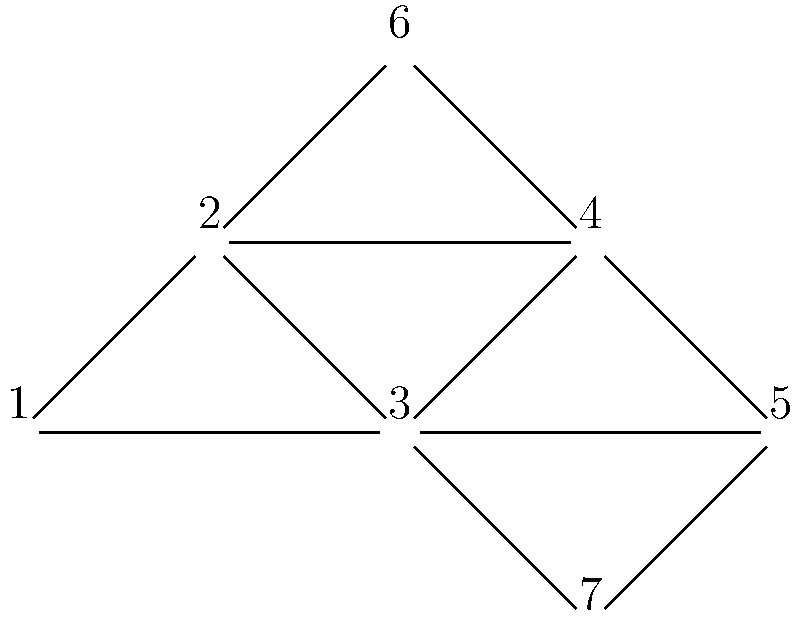Given the network graph above, determine the node with the highest betweenness centrality and identify the most likely number of communities using the Girvan-Newman algorithm. Explain your reasoning for both parts. 1. Betweenness Centrality:
   - Betweenness centrality measures the number of shortest paths that pass through a node.
   - We need to consider all pairs of nodes and count how many shortest paths go through each node.
   - Node 3 appears to be on many shortest paths:
     * It connects nodes 1 and 5 to nodes 4 and 7
     * It's on the path between nodes 6 and 7
     * It's central in connecting the upper and lower parts of the graph
   - While node 2 is also central, it doesn't appear to be on as many shortest paths as node 3.

2. Community Detection using Girvan-Newman:
   - The Girvan-Newman algorithm works by progressively removing edges with high betweenness.
   - Looking at the graph structure:
     a) There's a triangular core (nodes 1, 2, 3)
     b) Two branches: one upper (nodes 1, 3, 6) and one lower (nodes 2, 4, 7)
   - The first edge to be removed would likely be between nodes 2 and 3, as it has high betweenness.
   - This removal would create three distinct communities:
     1) Nodes 1, 3, 6
     2) Node 2
     3) Nodes 4, 7
   - Further removals might separate node 5, but three communities seem most stable.

Therefore, node 3 has the highest betweenness centrality, and the most likely number of communities is 3.
Answer: Node 3; 3 communities 